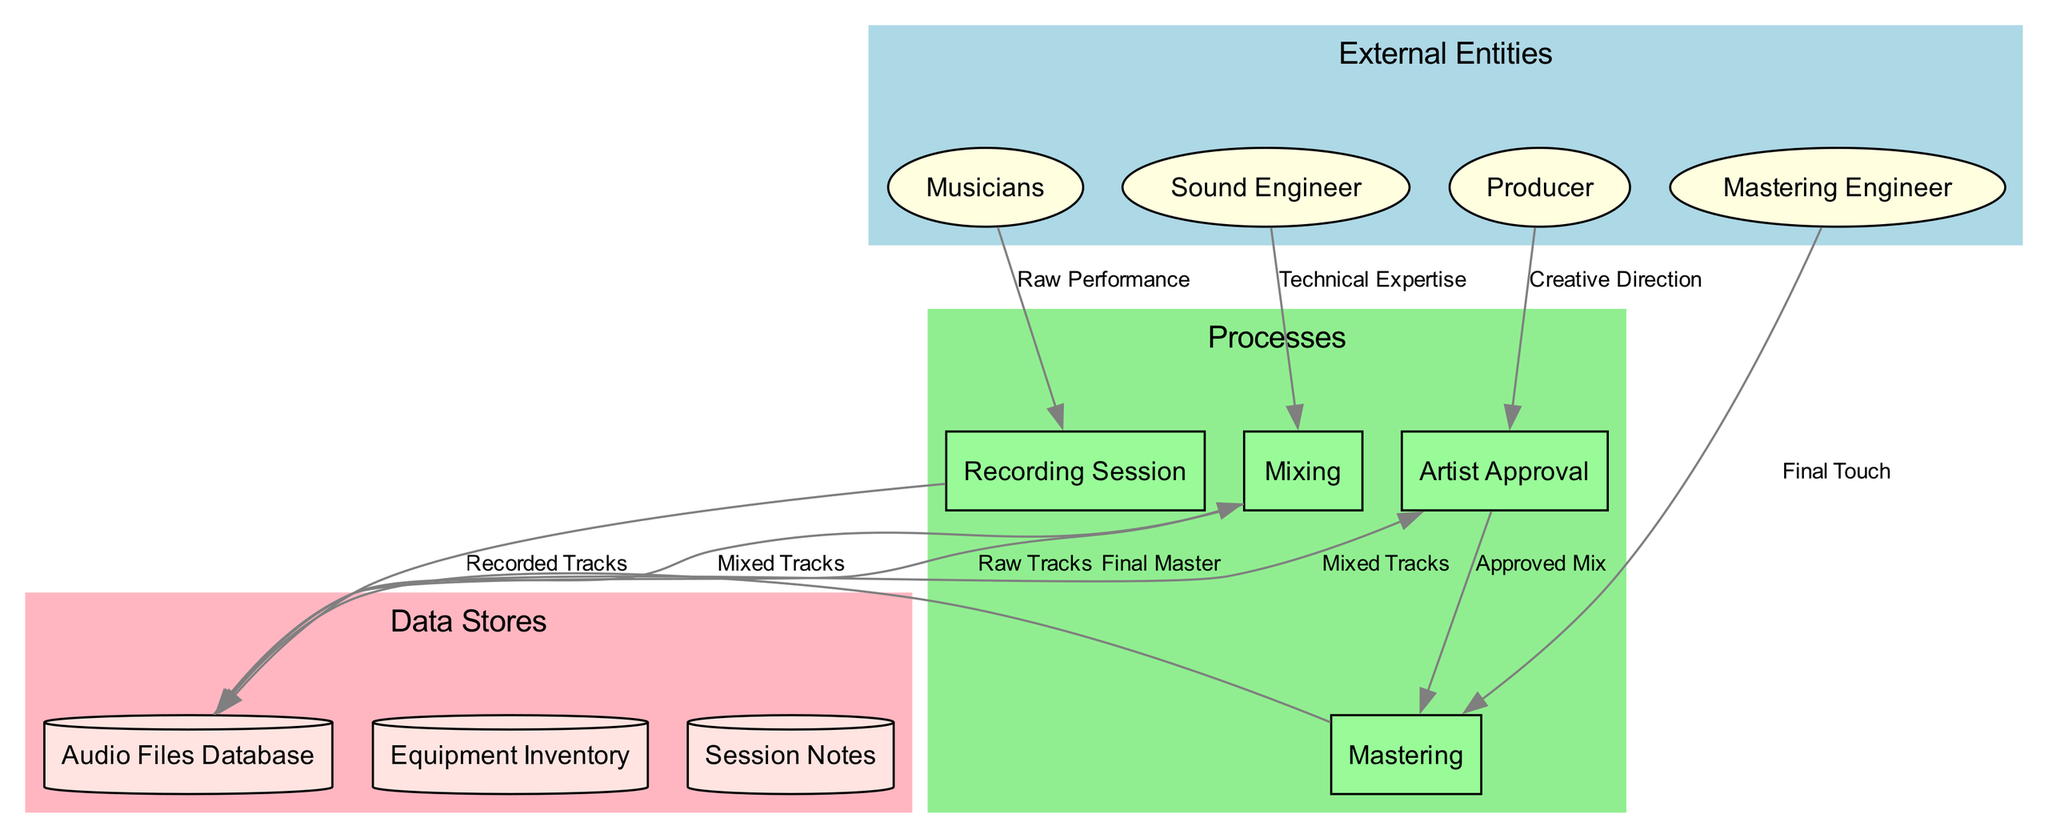What are the external entities involved in the workflow? The diagram lists four external entities: Musicians, Sound Engineer, Producer, and Mastering Engineer. These are identified within the "External Entities" cluster of the diagram.
Answer: Musicians, Sound Engineer, Producer, Mastering Engineer How many processes are there in the diagram? The diagram showcases four processes, which are Recording Session, Mixing, Mastering, and Artist Approval. These processes are indicated in the "Processes" cluster.
Answer: 4 What is the data flow from Musicians to Recording Session labeled as? The diagram indicates that the data flow from Musicians to Recording Session is labeled as "Raw Performance." This labeling is found along the connecting edge between these two nodes.
Answer: Raw Performance Which node sends "Final Touch" to the Mastering node? According to the diagram, the Mastering Engineer is the node that sends "Final Touch" to the Mastering node, which can be traced through the connecting edge on the diagram.
Answer: Mastering Engineer What data flow moves from Mixing to Audio Files Database? The data flow from Mixing to Audio Files Database is labeled as "Mixed Tracks." This information is found on the edge connecting these two nodes in the diagram.
Answer: Mixed Tracks Which process comes directly before Mastering in the workflow? The process that comes directly before Mastering in the workflow is Artist Approval, as indicated by the directed flow from Artist Approval to Mastering in the diagram.
Answer: Artist Approval What is the purpose of the flow labeled "Approved Mix"? The flow labeled "Approved Mix" serves as the data that transitions from the Artist Approval process to the Mastering process, indicating the point at which the mix is approved before final mastering.
Answer: Approved Mix What is the total number of data stores in the diagram? The diagram illustrates three data stores: Audio Files Database, Equipment Inventory, and Session Notes. These are listed in the "Data Stores" cluster of the diagram.
Answer: 3 What is the role of the Sound Engineer in the workflow? The role of the Sound Engineer in the workflow is to provide "Technical Expertise" to the Mixing process, which is represented through the data flow from Sound Engineer to Mixing in the diagram.
Answer: Technical Expertise 